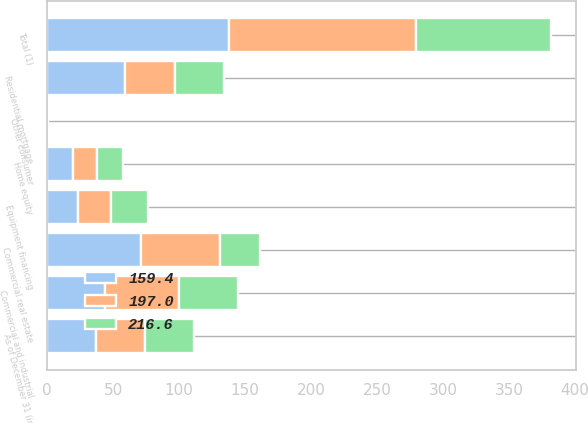<chart> <loc_0><loc_0><loc_500><loc_500><stacked_bar_chart><ecel><fcel>As of December 31 (in<fcel>Commercial and industrial<fcel>Commercial real estate<fcel>Equipment financing<fcel>Total (1)<fcel>Residential mortgage<fcel>Home equity<fcel>Other consumer<nl><fcel>216.6<fcel>37.2<fcel>44.9<fcel>30.2<fcel>27.5<fcel>102.6<fcel>37.2<fcel>19.5<fcel>0.1<nl><fcel>197<fcel>37.2<fcel>55.8<fcel>60.2<fcel>25.4<fcel>141.4<fcel>37.6<fcel>17.9<fcel>0.1<nl><fcel>159.4<fcel>37.2<fcel>43.8<fcel>70.8<fcel>23.2<fcel>137.8<fcel>58.9<fcel>19.8<fcel>0.1<nl></chart> 